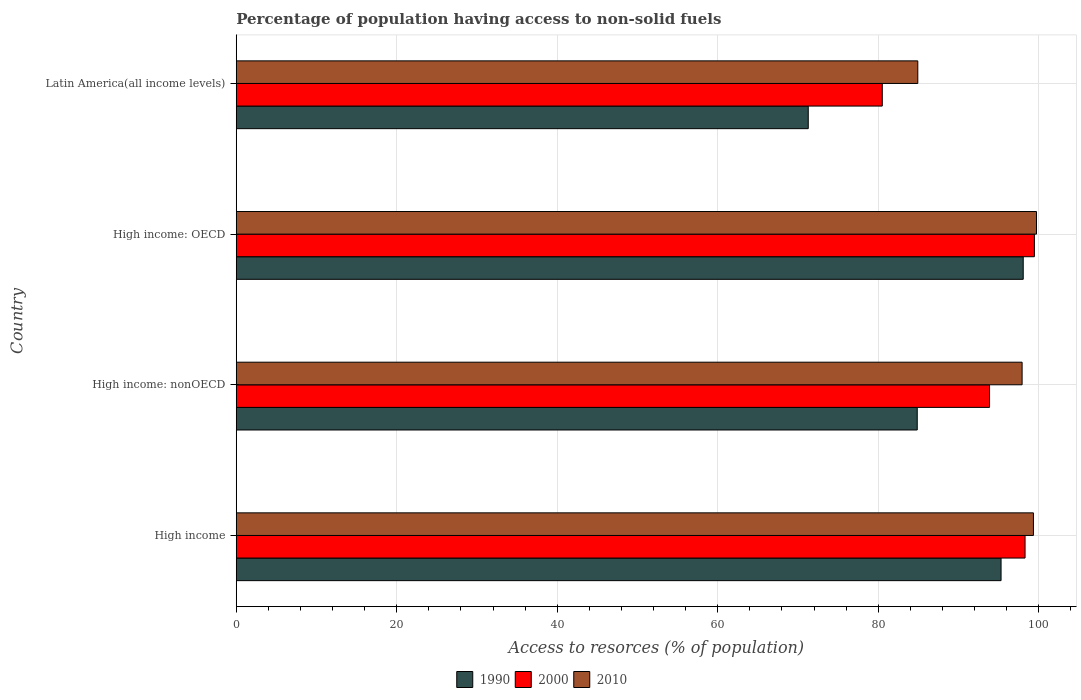How many different coloured bars are there?
Give a very brief answer. 3. How many groups of bars are there?
Keep it short and to the point. 4. Are the number of bars per tick equal to the number of legend labels?
Your response must be concise. Yes. How many bars are there on the 2nd tick from the top?
Your answer should be compact. 3. What is the label of the 2nd group of bars from the top?
Ensure brevity in your answer.  High income: OECD. What is the percentage of population having access to non-solid fuels in 1990 in Latin America(all income levels)?
Your response must be concise. 71.28. Across all countries, what is the maximum percentage of population having access to non-solid fuels in 2010?
Offer a very short reply. 99.72. Across all countries, what is the minimum percentage of population having access to non-solid fuels in 2010?
Your response must be concise. 84.93. In which country was the percentage of population having access to non-solid fuels in 2000 maximum?
Make the answer very short. High income: OECD. In which country was the percentage of population having access to non-solid fuels in 2000 minimum?
Offer a terse response. Latin America(all income levels). What is the total percentage of population having access to non-solid fuels in 1990 in the graph?
Your answer should be compact. 349.51. What is the difference between the percentage of population having access to non-solid fuels in 2010 in High income: OECD and that in High income: nonOECD?
Provide a short and direct response. 1.79. What is the difference between the percentage of population having access to non-solid fuels in 2010 in High income: OECD and the percentage of population having access to non-solid fuels in 2000 in High income?
Offer a terse response. 1.42. What is the average percentage of population having access to non-solid fuels in 1990 per country?
Your response must be concise. 87.38. What is the difference between the percentage of population having access to non-solid fuels in 1990 and percentage of population having access to non-solid fuels in 2010 in High income?
Your answer should be compact. -4.04. What is the ratio of the percentage of population having access to non-solid fuels in 1990 in High income: OECD to that in Latin America(all income levels)?
Your response must be concise. 1.38. Is the percentage of population having access to non-solid fuels in 2010 in High income less than that in High income: OECD?
Keep it short and to the point. Yes. Is the difference between the percentage of population having access to non-solid fuels in 1990 in High income: OECD and High income: nonOECD greater than the difference between the percentage of population having access to non-solid fuels in 2010 in High income: OECD and High income: nonOECD?
Your answer should be very brief. Yes. What is the difference between the highest and the second highest percentage of population having access to non-solid fuels in 2010?
Your answer should be compact. 0.38. What is the difference between the highest and the lowest percentage of population having access to non-solid fuels in 2000?
Provide a short and direct response. 18.96. In how many countries, is the percentage of population having access to non-solid fuels in 2000 greater than the average percentage of population having access to non-solid fuels in 2000 taken over all countries?
Your answer should be compact. 3. What does the 3rd bar from the bottom in High income represents?
Make the answer very short. 2010. How many bars are there?
Give a very brief answer. 12. Are all the bars in the graph horizontal?
Keep it short and to the point. Yes. Are the values on the major ticks of X-axis written in scientific E-notation?
Offer a very short reply. No. Where does the legend appear in the graph?
Your answer should be compact. Bottom center. What is the title of the graph?
Give a very brief answer. Percentage of population having access to non-solid fuels. What is the label or title of the X-axis?
Your answer should be compact. Access to resorces (% of population). What is the Access to resorces (% of population) of 1990 in High income?
Ensure brevity in your answer.  95.31. What is the Access to resorces (% of population) in 2000 in High income?
Provide a short and direct response. 98.3. What is the Access to resorces (% of population) of 2010 in High income?
Offer a terse response. 99.34. What is the Access to resorces (% of population) in 1990 in High income: nonOECD?
Your answer should be very brief. 84.86. What is the Access to resorces (% of population) of 2000 in High income: nonOECD?
Provide a short and direct response. 93.87. What is the Access to resorces (% of population) of 2010 in High income: nonOECD?
Your answer should be very brief. 97.93. What is the Access to resorces (% of population) in 1990 in High income: OECD?
Your answer should be very brief. 98.07. What is the Access to resorces (% of population) of 2000 in High income: OECD?
Your answer should be very brief. 99.46. What is the Access to resorces (% of population) in 2010 in High income: OECD?
Your answer should be very brief. 99.72. What is the Access to resorces (% of population) in 1990 in Latin America(all income levels)?
Ensure brevity in your answer.  71.28. What is the Access to resorces (% of population) of 2000 in Latin America(all income levels)?
Keep it short and to the point. 80.51. What is the Access to resorces (% of population) in 2010 in Latin America(all income levels)?
Keep it short and to the point. 84.93. Across all countries, what is the maximum Access to resorces (% of population) in 1990?
Provide a short and direct response. 98.07. Across all countries, what is the maximum Access to resorces (% of population) of 2000?
Make the answer very short. 99.46. Across all countries, what is the maximum Access to resorces (% of population) of 2010?
Give a very brief answer. 99.72. Across all countries, what is the minimum Access to resorces (% of population) of 1990?
Keep it short and to the point. 71.28. Across all countries, what is the minimum Access to resorces (% of population) of 2000?
Your response must be concise. 80.51. Across all countries, what is the minimum Access to resorces (% of population) in 2010?
Give a very brief answer. 84.93. What is the total Access to resorces (% of population) in 1990 in the graph?
Your answer should be very brief. 349.51. What is the total Access to resorces (% of population) of 2000 in the graph?
Your answer should be very brief. 372.13. What is the total Access to resorces (% of population) of 2010 in the graph?
Your answer should be very brief. 381.92. What is the difference between the Access to resorces (% of population) of 1990 in High income and that in High income: nonOECD?
Offer a terse response. 10.45. What is the difference between the Access to resorces (% of population) of 2000 in High income and that in High income: nonOECD?
Give a very brief answer. 4.43. What is the difference between the Access to resorces (% of population) in 2010 in High income and that in High income: nonOECD?
Ensure brevity in your answer.  1.41. What is the difference between the Access to resorces (% of population) of 1990 in High income and that in High income: OECD?
Provide a short and direct response. -2.76. What is the difference between the Access to resorces (% of population) of 2000 in High income and that in High income: OECD?
Make the answer very short. -1.16. What is the difference between the Access to resorces (% of population) of 2010 in High income and that in High income: OECD?
Ensure brevity in your answer.  -0.38. What is the difference between the Access to resorces (% of population) in 1990 in High income and that in Latin America(all income levels)?
Ensure brevity in your answer.  24.03. What is the difference between the Access to resorces (% of population) in 2000 in High income and that in Latin America(all income levels)?
Offer a terse response. 17.79. What is the difference between the Access to resorces (% of population) of 2010 in High income and that in Latin America(all income levels)?
Offer a terse response. 14.41. What is the difference between the Access to resorces (% of population) of 1990 in High income: nonOECD and that in High income: OECD?
Give a very brief answer. -13.21. What is the difference between the Access to resorces (% of population) in 2000 in High income: nonOECD and that in High income: OECD?
Give a very brief answer. -5.59. What is the difference between the Access to resorces (% of population) of 2010 in High income: nonOECD and that in High income: OECD?
Your response must be concise. -1.79. What is the difference between the Access to resorces (% of population) of 1990 in High income: nonOECD and that in Latin America(all income levels)?
Your answer should be compact. 13.58. What is the difference between the Access to resorces (% of population) of 2000 in High income: nonOECD and that in Latin America(all income levels)?
Make the answer very short. 13.37. What is the difference between the Access to resorces (% of population) in 2010 in High income: nonOECD and that in Latin America(all income levels)?
Give a very brief answer. 13. What is the difference between the Access to resorces (% of population) in 1990 in High income: OECD and that in Latin America(all income levels)?
Your answer should be very brief. 26.79. What is the difference between the Access to resorces (% of population) in 2000 in High income: OECD and that in Latin America(all income levels)?
Provide a short and direct response. 18.96. What is the difference between the Access to resorces (% of population) of 2010 in High income: OECD and that in Latin America(all income levels)?
Your answer should be very brief. 14.79. What is the difference between the Access to resorces (% of population) in 1990 in High income and the Access to resorces (% of population) in 2000 in High income: nonOECD?
Ensure brevity in your answer.  1.44. What is the difference between the Access to resorces (% of population) in 1990 in High income and the Access to resorces (% of population) in 2010 in High income: nonOECD?
Give a very brief answer. -2.62. What is the difference between the Access to resorces (% of population) of 2000 in High income and the Access to resorces (% of population) of 2010 in High income: nonOECD?
Your answer should be compact. 0.37. What is the difference between the Access to resorces (% of population) in 1990 in High income and the Access to resorces (% of population) in 2000 in High income: OECD?
Your response must be concise. -4.15. What is the difference between the Access to resorces (% of population) in 1990 in High income and the Access to resorces (% of population) in 2010 in High income: OECD?
Your response must be concise. -4.41. What is the difference between the Access to resorces (% of population) in 2000 in High income and the Access to resorces (% of population) in 2010 in High income: OECD?
Provide a succinct answer. -1.42. What is the difference between the Access to resorces (% of population) in 1990 in High income and the Access to resorces (% of population) in 2000 in Latin America(all income levels)?
Make the answer very short. 14.8. What is the difference between the Access to resorces (% of population) of 1990 in High income and the Access to resorces (% of population) of 2010 in Latin America(all income levels)?
Ensure brevity in your answer.  10.37. What is the difference between the Access to resorces (% of population) in 2000 in High income and the Access to resorces (% of population) in 2010 in Latin America(all income levels)?
Provide a short and direct response. 13.37. What is the difference between the Access to resorces (% of population) in 1990 in High income: nonOECD and the Access to resorces (% of population) in 2000 in High income: OECD?
Ensure brevity in your answer.  -14.6. What is the difference between the Access to resorces (% of population) in 1990 in High income: nonOECD and the Access to resorces (% of population) in 2010 in High income: OECD?
Give a very brief answer. -14.86. What is the difference between the Access to resorces (% of population) in 2000 in High income: nonOECD and the Access to resorces (% of population) in 2010 in High income: OECD?
Offer a terse response. -5.85. What is the difference between the Access to resorces (% of population) of 1990 in High income: nonOECD and the Access to resorces (% of population) of 2000 in Latin America(all income levels)?
Provide a succinct answer. 4.35. What is the difference between the Access to resorces (% of population) of 1990 in High income: nonOECD and the Access to resorces (% of population) of 2010 in Latin America(all income levels)?
Your response must be concise. -0.07. What is the difference between the Access to resorces (% of population) of 2000 in High income: nonOECD and the Access to resorces (% of population) of 2010 in Latin America(all income levels)?
Your answer should be compact. 8.94. What is the difference between the Access to resorces (% of population) of 1990 in High income: OECD and the Access to resorces (% of population) of 2000 in Latin America(all income levels)?
Keep it short and to the point. 17.56. What is the difference between the Access to resorces (% of population) of 1990 in High income: OECD and the Access to resorces (% of population) of 2010 in Latin America(all income levels)?
Your response must be concise. 13.14. What is the difference between the Access to resorces (% of population) of 2000 in High income: OECD and the Access to resorces (% of population) of 2010 in Latin America(all income levels)?
Your response must be concise. 14.53. What is the average Access to resorces (% of population) of 1990 per country?
Your response must be concise. 87.38. What is the average Access to resorces (% of population) of 2000 per country?
Your answer should be very brief. 93.03. What is the average Access to resorces (% of population) in 2010 per country?
Provide a short and direct response. 95.48. What is the difference between the Access to resorces (% of population) in 1990 and Access to resorces (% of population) in 2000 in High income?
Provide a succinct answer. -2.99. What is the difference between the Access to resorces (% of population) of 1990 and Access to resorces (% of population) of 2010 in High income?
Give a very brief answer. -4.04. What is the difference between the Access to resorces (% of population) of 2000 and Access to resorces (% of population) of 2010 in High income?
Provide a short and direct response. -1.04. What is the difference between the Access to resorces (% of population) in 1990 and Access to resorces (% of population) in 2000 in High income: nonOECD?
Your response must be concise. -9.01. What is the difference between the Access to resorces (% of population) in 1990 and Access to resorces (% of population) in 2010 in High income: nonOECD?
Your answer should be compact. -13.07. What is the difference between the Access to resorces (% of population) in 2000 and Access to resorces (% of population) in 2010 in High income: nonOECD?
Offer a terse response. -4.06. What is the difference between the Access to resorces (% of population) of 1990 and Access to resorces (% of population) of 2000 in High income: OECD?
Your response must be concise. -1.39. What is the difference between the Access to resorces (% of population) of 1990 and Access to resorces (% of population) of 2010 in High income: OECD?
Give a very brief answer. -1.65. What is the difference between the Access to resorces (% of population) in 2000 and Access to resorces (% of population) in 2010 in High income: OECD?
Your answer should be compact. -0.26. What is the difference between the Access to resorces (% of population) in 1990 and Access to resorces (% of population) in 2000 in Latin America(all income levels)?
Keep it short and to the point. -9.23. What is the difference between the Access to resorces (% of population) of 1990 and Access to resorces (% of population) of 2010 in Latin America(all income levels)?
Ensure brevity in your answer.  -13.65. What is the difference between the Access to resorces (% of population) of 2000 and Access to resorces (% of population) of 2010 in Latin America(all income levels)?
Make the answer very short. -4.43. What is the ratio of the Access to resorces (% of population) of 1990 in High income to that in High income: nonOECD?
Keep it short and to the point. 1.12. What is the ratio of the Access to resorces (% of population) of 2000 in High income to that in High income: nonOECD?
Your answer should be very brief. 1.05. What is the ratio of the Access to resorces (% of population) in 2010 in High income to that in High income: nonOECD?
Ensure brevity in your answer.  1.01. What is the ratio of the Access to resorces (% of population) in 1990 in High income to that in High income: OECD?
Make the answer very short. 0.97. What is the ratio of the Access to resorces (% of population) of 2000 in High income to that in High income: OECD?
Ensure brevity in your answer.  0.99. What is the ratio of the Access to resorces (% of population) of 2010 in High income to that in High income: OECD?
Keep it short and to the point. 1. What is the ratio of the Access to resorces (% of population) in 1990 in High income to that in Latin America(all income levels)?
Your answer should be compact. 1.34. What is the ratio of the Access to resorces (% of population) in 2000 in High income to that in Latin America(all income levels)?
Offer a very short reply. 1.22. What is the ratio of the Access to resorces (% of population) of 2010 in High income to that in Latin America(all income levels)?
Ensure brevity in your answer.  1.17. What is the ratio of the Access to resorces (% of population) in 1990 in High income: nonOECD to that in High income: OECD?
Your response must be concise. 0.87. What is the ratio of the Access to resorces (% of population) in 2000 in High income: nonOECD to that in High income: OECD?
Give a very brief answer. 0.94. What is the ratio of the Access to resorces (% of population) in 2010 in High income: nonOECD to that in High income: OECD?
Your answer should be compact. 0.98. What is the ratio of the Access to resorces (% of population) of 1990 in High income: nonOECD to that in Latin America(all income levels)?
Your answer should be compact. 1.19. What is the ratio of the Access to resorces (% of population) of 2000 in High income: nonOECD to that in Latin America(all income levels)?
Provide a short and direct response. 1.17. What is the ratio of the Access to resorces (% of population) in 2010 in High income: nonOECD to that in Latin America(all income levels)?
Make the answer very short. 1.15. What is the ratio of the Access to resorces (% of population) in 1990 in High income: OECD to that in Latin America(all income levels)?
Your answer should be very brief. 1.38. What is the ratio of the Access to resorces (% of population) in 2000 in High income: OECD to that in Latin America(all income levels)?
Your answer should be compact. 1.24. What is the ratio of the Access to resorces (% of population) of 2010 in High income: OECD to that in Latin America(all income levels)?
Keep it short and to the point. 1.17. What is the difference between the highest and the second highest Access to resorces (% of population) of 1990?
Your answer should be very brief. 2.76. What is the difference between the highest and the second highest Access to resorces (% of population) in 2000?
Your response must be concise. 1.16. What is the difference between the highest and the second highest Access to resorces (% of population) in 2010?
Provide a succinct answer. 0.38. What is the difference between the highest and the lowest Access to resorces (% of population) of 1990?
Ensure brevity in your answer.  26.79. What is the difference between the highest and the lowest Access to resorces (% of population) of 2000?
Give a very brief answer. 18.96. What is the difference between the highest and the lowest Access to resorces (% of population) in 2010?
Your answer should be very brief. 14.79. 